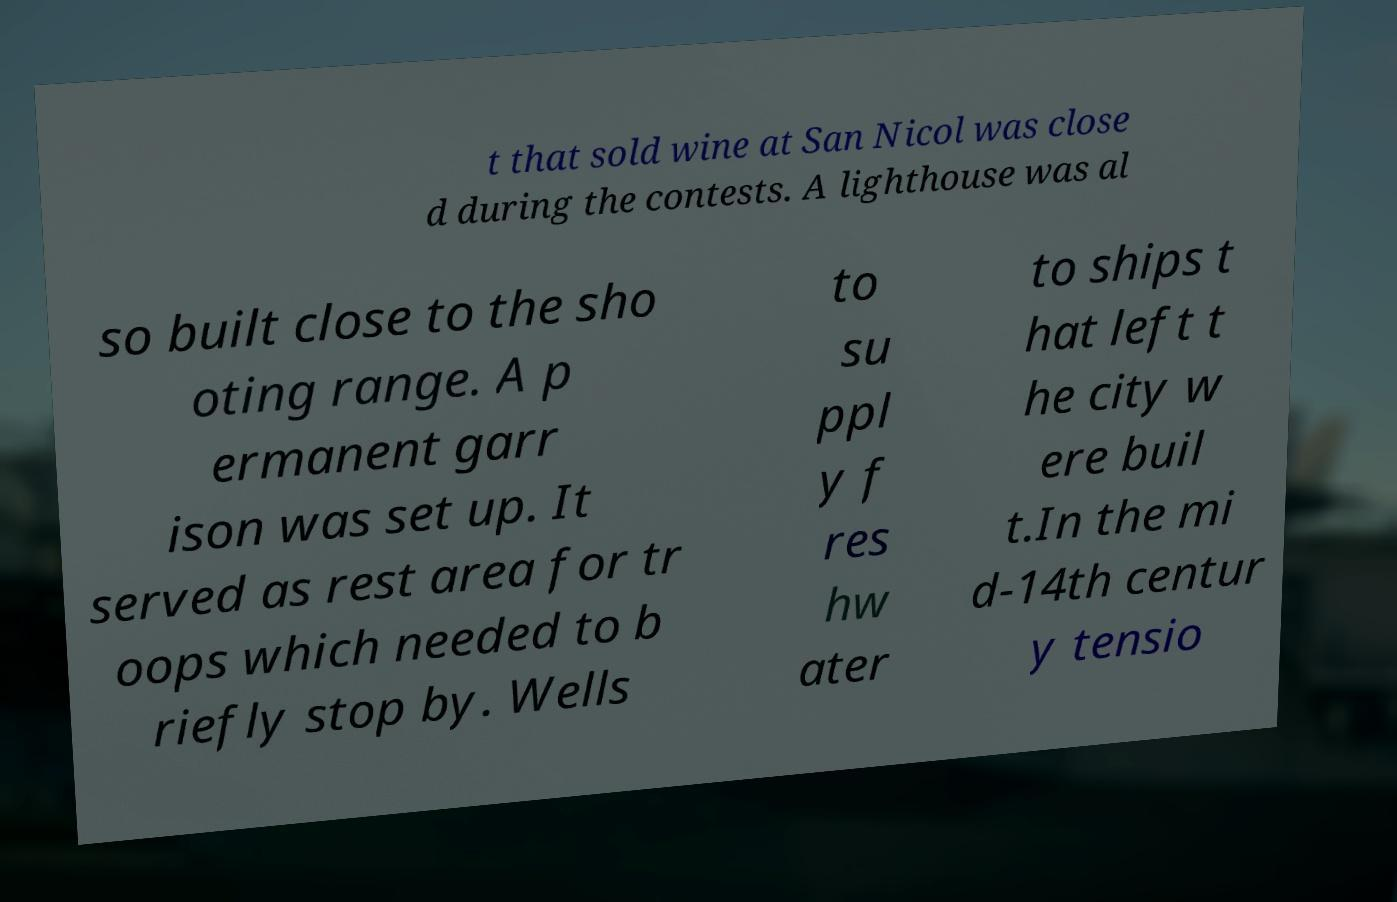There's text embedded in this image that I need extracted. Can you transcribe it verbatim? t that sold wine at San Nicol was close d during the contests. A lighthouse was al so built close to the sho oting range. A p ermanent garr ison was set up. It served as rest area for tr oops which needed to b riefly stop by. Wells to su ppl y f res hw ater to ships t hat left t he city w ere buil t.In the mi d-14th centur y tensio 